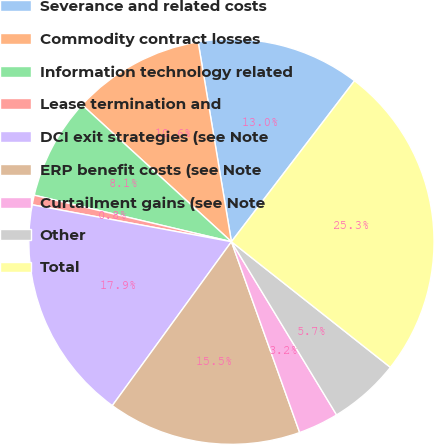Convert chart. <chart><loc_0><loc_0><loc_500><loc_500><pie_chart><fcel>Severance and related costs<fcel>Commodity contract losses<fcel>Information technology related<fcel>Lease termination and<fcel>DCI exit strategies (see Note<fcel>ERP benefit costs (see Note<fcel>Curtailment gains (see Note<fcel>Other<fcel>Total<nl><fcel>13.02%<fcel>10.57%<fcel>8.12%<fcel>0.77%<fcel>17.92%<fcel>15.47%<fcel>3.22%<fcel>5.67%<fcel>25.26%<nl></chart> 